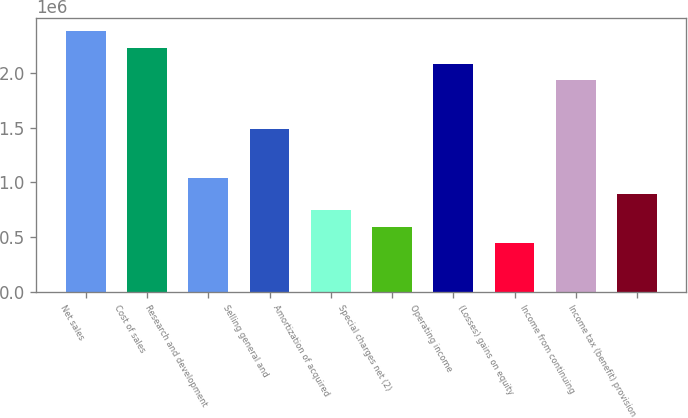<chart> <loc_0><loc_0><loc_500><loc_500><bar_chart><fcel>Net sales<fcel>Cost of sales<fcel>Research and development<fcel>Selling general and<fcel>Amortization of acquired<fcel>Special charges net (2)<fcel>Operating income<fcel>(Losses) gains on equity<fcel>Income from continuing<fcel>Income tax (benefit) provision<nl><fcel>2.37953e+06<fcel>2.23081e+06<fcel>1.04104e+06<fcel>1.4872e+06<fcel>743603<fcel>594883<fcel>2.08209e+06<fcel>446162<fcel>1.93337e+06<fcel>892324<nl></chart> 